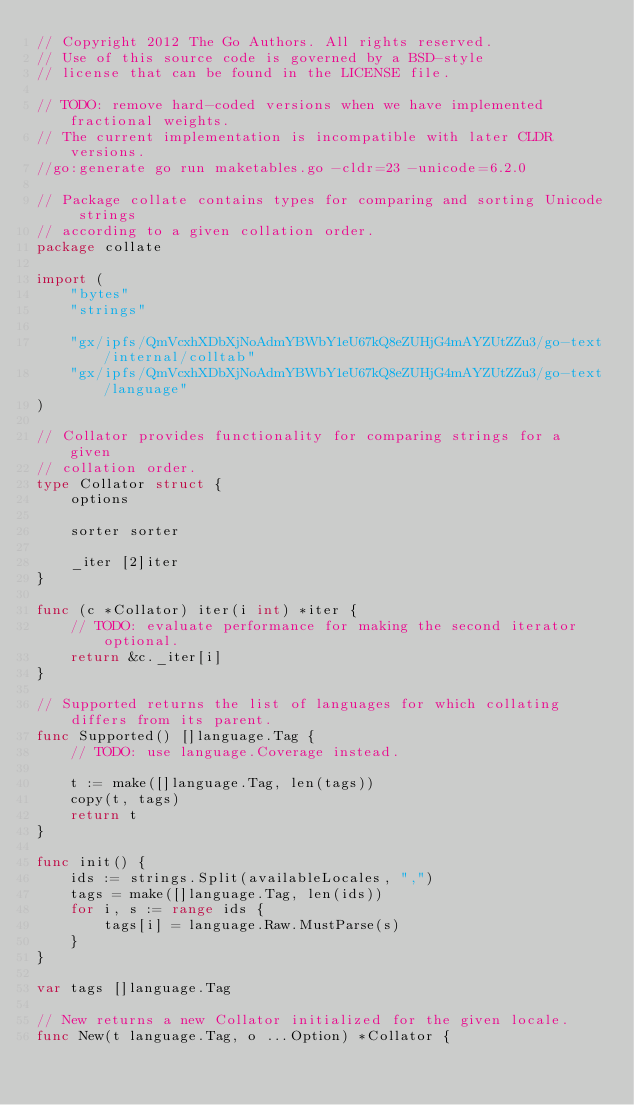<code> <loc_0><loc_0><loc_500><loc_500><_Go_>// Copyright 2012 The Go Authors. All rights reserved.
// Use of this source code is governed by a BSD-style
// license that can be found in the LICENSE file.

// TODO: remove hard-coded versions when we have implemented fractional weights.
// The current implementation is incompatible with later CLDR versions.
//go:generate go run maketables.go -cldr=23 -unicode=6.2.0

// Package collate contains types for comparing and sorting Unicode strings
// according to a given collation order.
package collate

import (
	"bytes"
	"strings"

	"gx/ipfs/QmVcxhXDbXjNoAdmYBWbY1eU67kQ8eZUHjG4mAYZUtZZu3/go-text/internal/colltab"
	"gx/ipfs/QmVcxhXDbXjNoAdmYBWbY1eU67kQ8eZUHjG4mAYZUtZZu3/go-text/language"
)

// Collator provides functionality for comparing strings for a given
// collation order.
type Collator struct {
	options

	sorter sorter

	_iter [2]iter
}

func (c *Collator) iter(i int) *iter {
	// TODO: evaluate performance for making the second iterator optional.
	return &c._iter[i]
}

// Supported returns the list of languages for which collating differs from its parent.
func Supported() []language.Tag {
	// TODO: use language.Coverage instead.

	t := make([]language.Tag, len(tags))
	copy(t, tags)
	return t
}

func init() {
	ids := strings.Split(availableLocales, ",")
	tags = make([]language.Tag, len(ids))
	for i, s := range ids {
		tags[i] = language.Raw.MustParse(s)
	}
}

var tags []language.Tag

// New returns a new Collator initialized for the given locale.
func New(t language.Tag, o ...Option) *Collator {</code> 